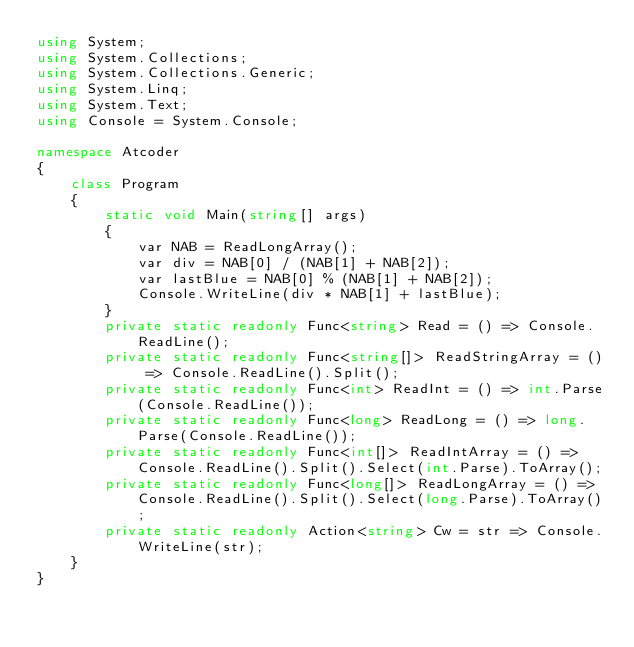Convert code to text. <code><loc_0><loc_0><loc_500><loc_500><_C#_>using System;
using System.Collections;
using System.Collections.Generic;
using System.Linq;
using System.Text;
using Console = System.Console;

namespace Atcoder
{
    class Program
    {
        static void Main(string[] args)
        {
            var NAB = ReadLongArray();
            var div = NAB[0] / (NAB[1] + NAB[2]);
            var lastBlue = NAB[0] % (NAB[1] + NAB[2]);
            Console.WriteLine(div * NAB[1] + lastBlue);
        }
        private static readonly Func<string> Read = () => Console.ReadLine();
        private static readonly Func<string[]> ReadStringArray = () => Console.ReadLine().Split();
        private static readonly Func<int> ReadInt = () => int.Parse(Console.ReadLine());
        private static readonly Func<long> ReadLong = () => long.Parse(Console.ReadLine());
        private static readonly Func<int[]> ReadIntArray = () => Console.ReadLine().Split().Select(int.Parse).ToArray();
        private static readonly Func<long[]> ReadLongArray = () => Console.ReadLine().Split().Select(long.Parse).ToArray();
        private static readonly Action<string> Cw = str => Console.WriteLine(str);
    }
}</code> 